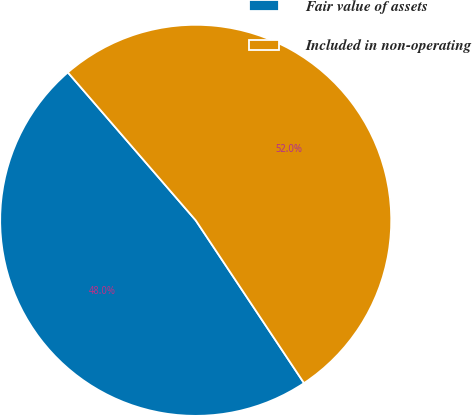Convert chart to OTSL. <chart><loc_0><loc_0><loc_500><loc_500><pie_chart><fcel>Fair value of assets<fcel>Included in non-operating<nl><fcel>48.0%<fcel>52.0%<nl></chart> 